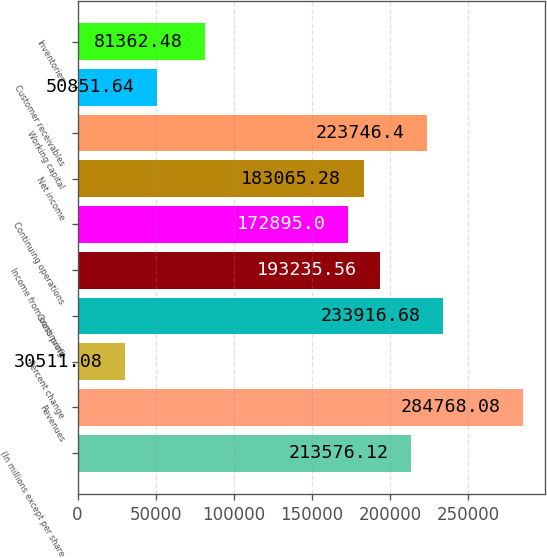Convert chart. <chart><loc_0><loc_0><loc_500><loc_500><bar_chart><fcel>(In millions except per share<fcel>Revenues<fcel>Percent change<fcel>Gross profit<fcel>Income from continuing<fcel>Continuing operations<fcel>Net income<fcel>Working capital<fcel>Customer receivables<fcel>Inventories<nl><fcel>213576<fcel>284768<fcel>30511.1<fcel>233917<fcel>193236<fcel>172895<fcel>183065<fcel>223746<fcel>50851.6<fcel>81362.5<nl></chart> 